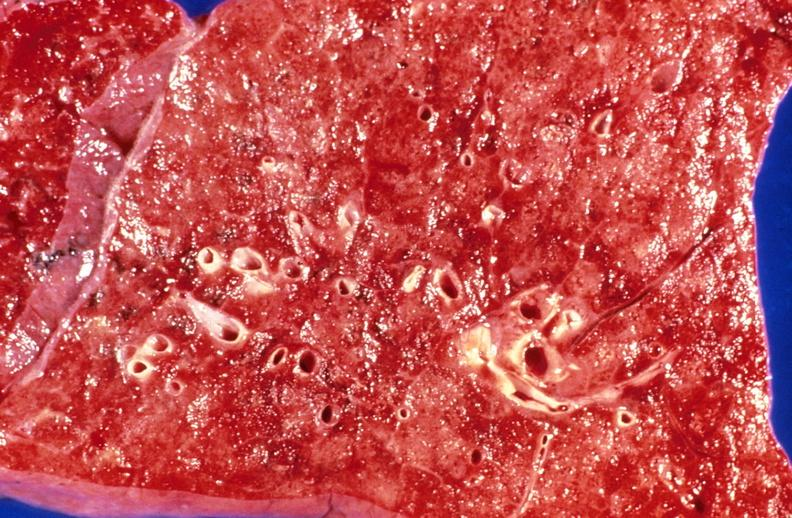what is present?
Answer the question using a single word or phrase. Respiratory 